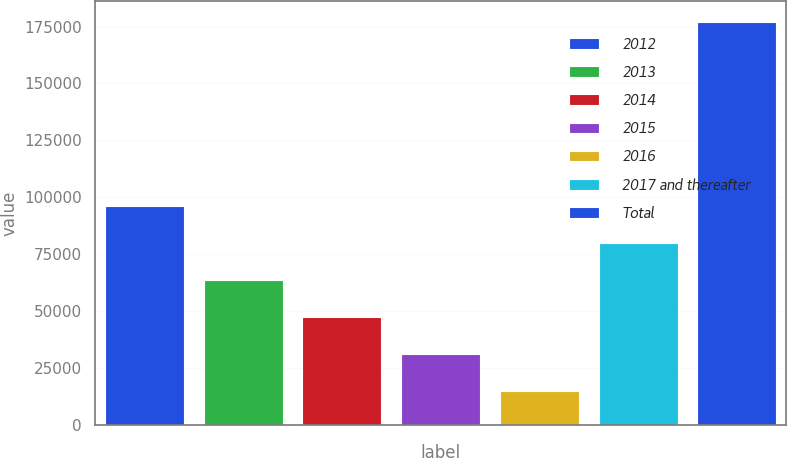Convert chart to OTSL. <chart><loc_0><loc_0><loc_500><loc_500><bar_chart><fcel>2012<fcel>2013<fcel>2014<fcel>2015<fcel>2016<fcel>2017 and thereafter<fcel>Total<nl><fcel>96166<fcel>63766<fcel>47566<fcel>31366<fcel>15166<fcel>79966<fcel>177166<nl></chart> 